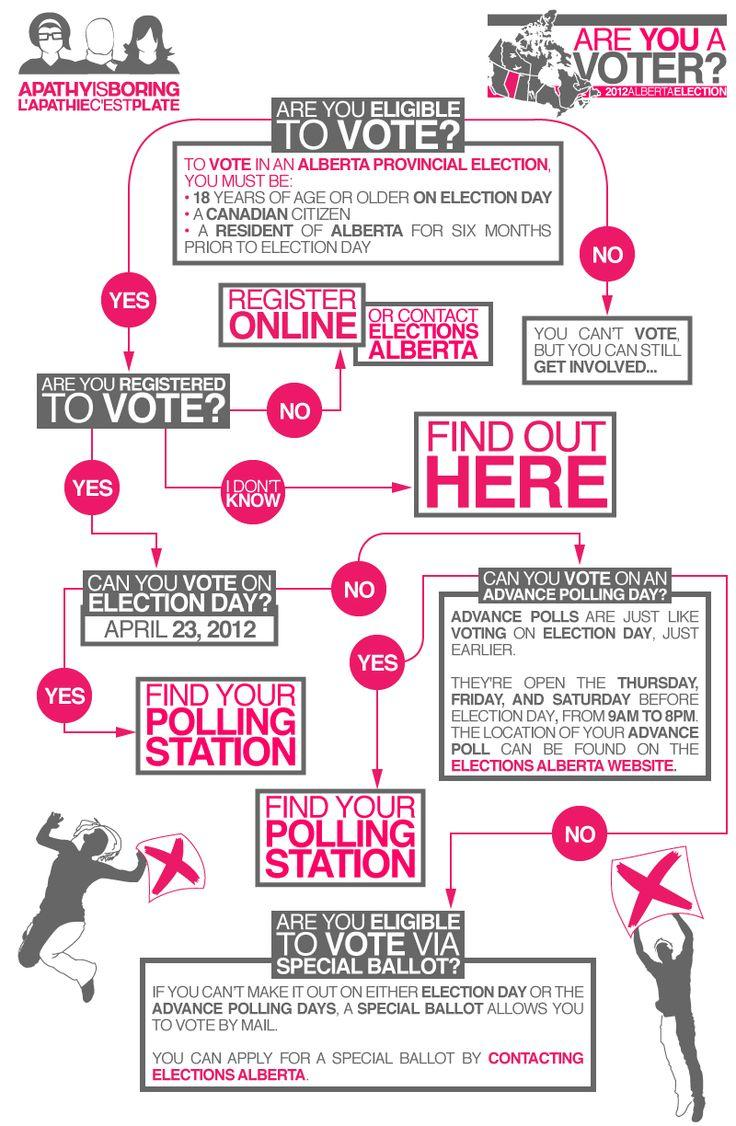List a handful of essential elements in this visual. If a person is not a registered voter, they should register online to ensure their ability to participate in the democratic process. 